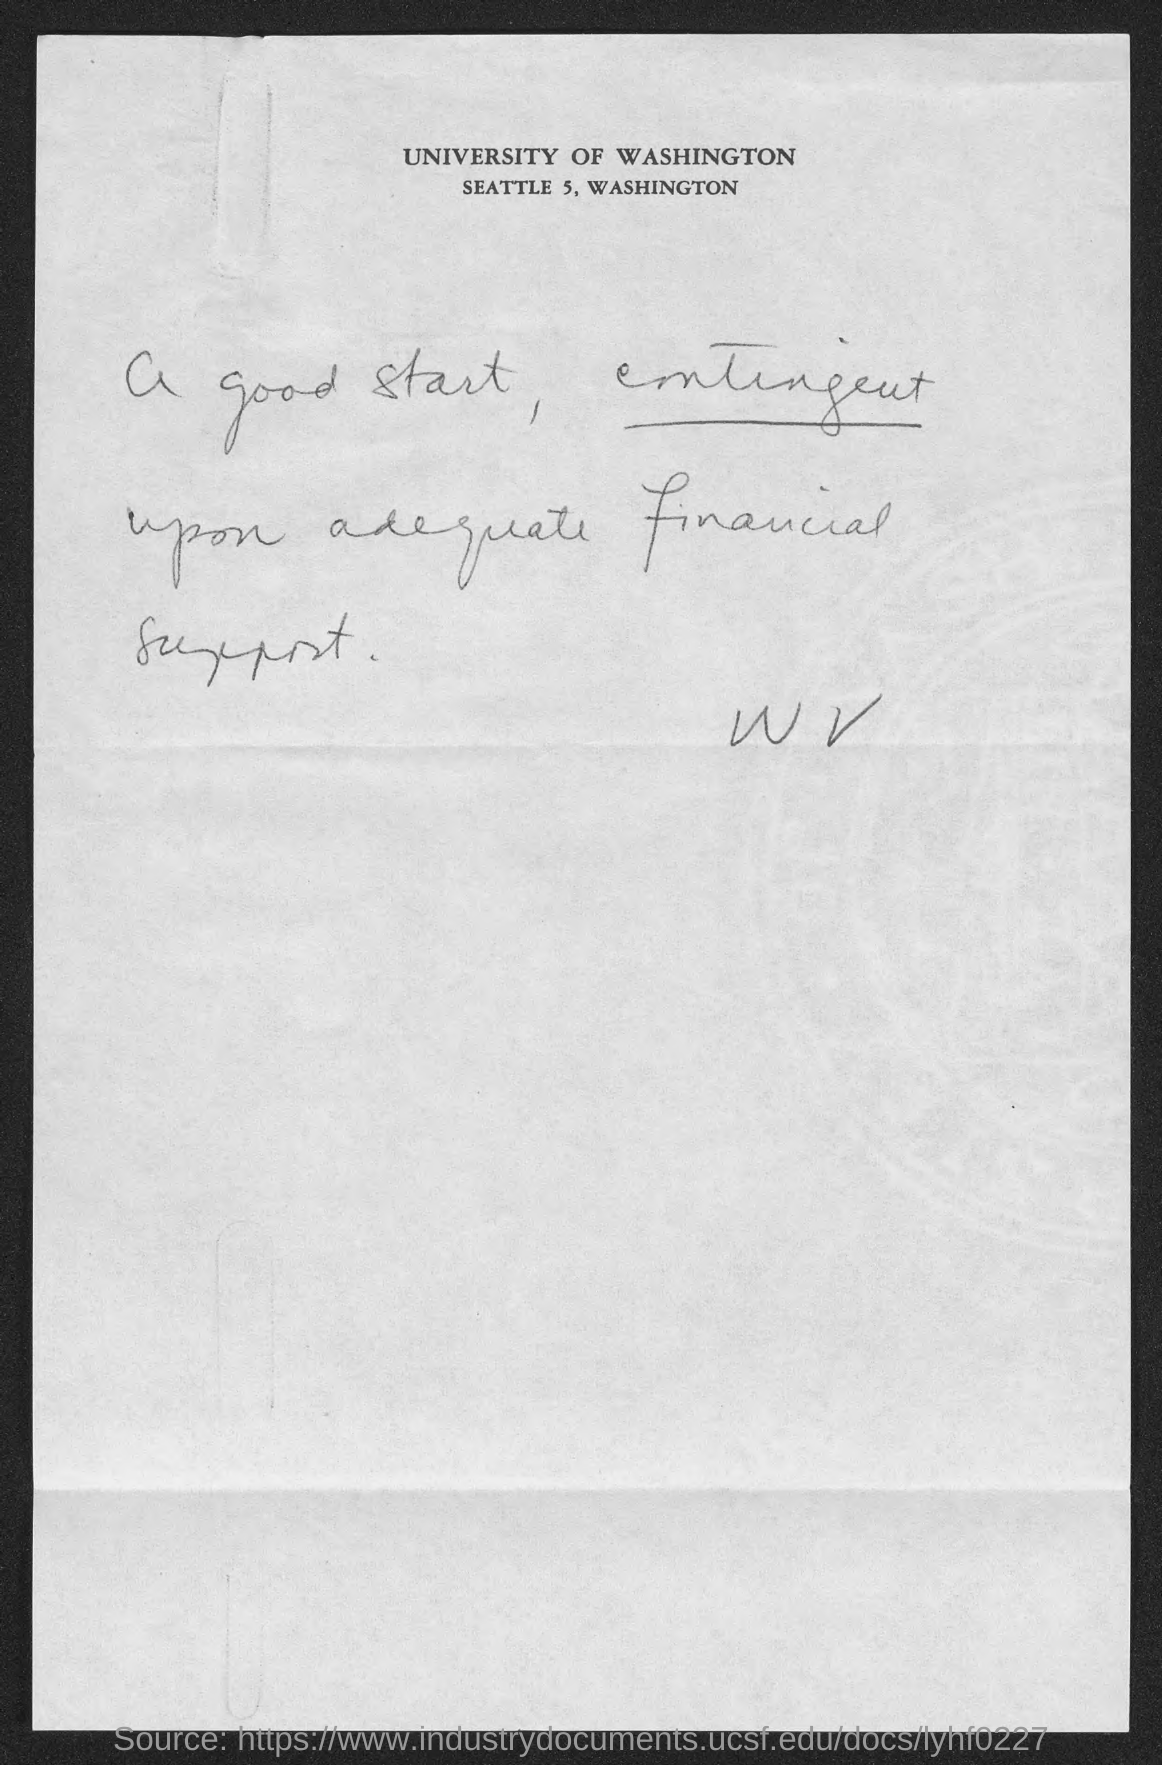What is the address of university of washington ?
Your answer should be very brief. Seattle 5, Washington. 